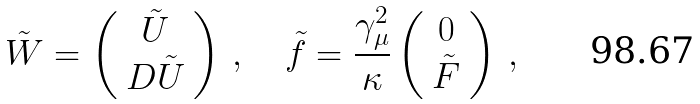Convert formula to latex. <formula><loc_0><loc_0><loc_500><loc_500>\tilde { W } = \left ( \begin{array} { c } \tilde { U } \\ D \tilde { U } \end{array} \right ) \, , \quad \tilde { f } = \frac { \gamma _ { \mu } ^ { 2 } } { \kappa } \left ( \begin{array} { c } 0 \\ \tilde { F } \end{array} \right ) \, ,</formula> 